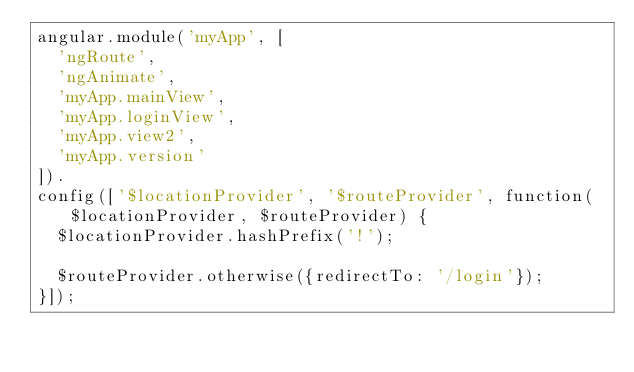<code> <loc_0><loc_0><loc_500><loc_500><_JavaScript_>angular.module('myApp', [
  'ngRoute',
  'ngAnimate',
  'myApp.mainView',
  'myApp.loginView',
  'myApp.view2',
  'myApp.version'
]).
config(['$locationProvider', '$routeProvider', function($locationProvider, $routeProvider) {
  $locationProvider.hashPrefix('!');

  $routeProvider.otherwise({redirectTo: '/login'});
}]);
</code> 